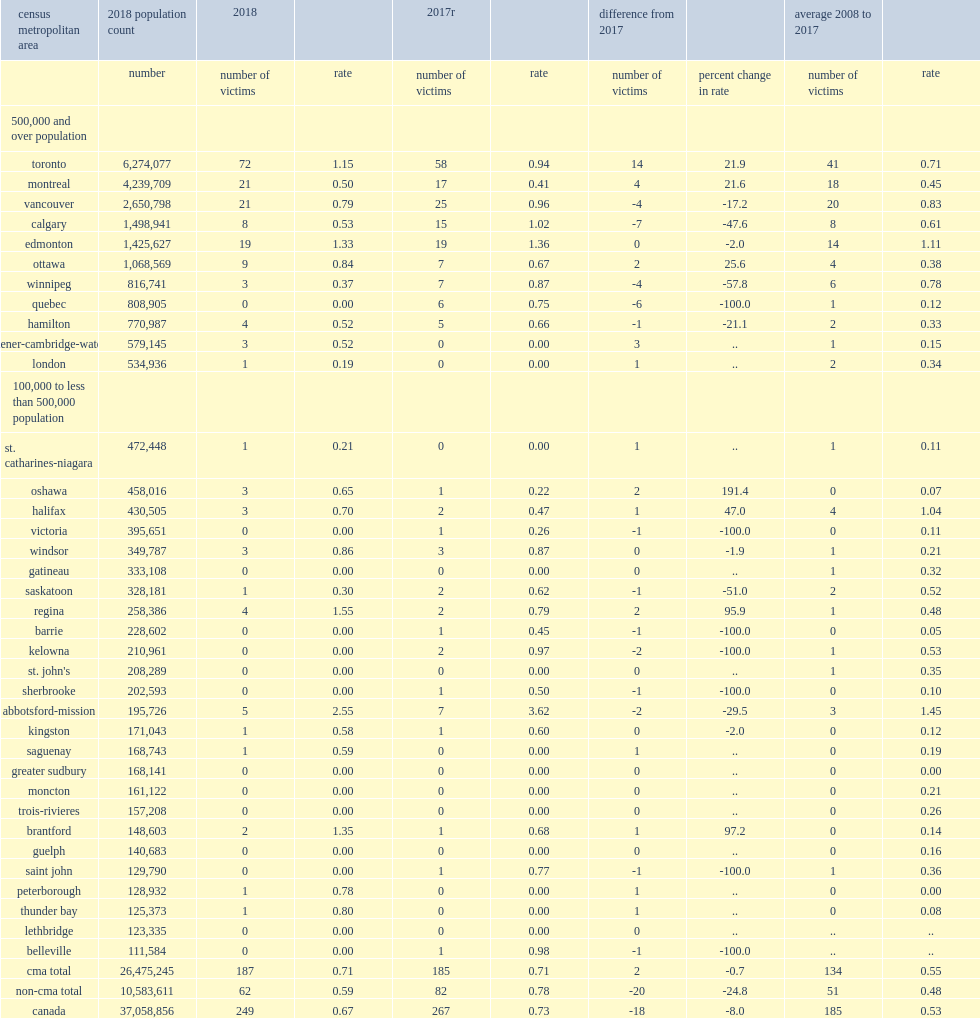List the top2 cmas reported the largest declines. Calgary quebec. What was the rate of firearm-related homicides reported in calgary in 2017? 1.02. Which cma reported the highest rate of firearm-related homicides in 2018. Abbotsford-mission. 